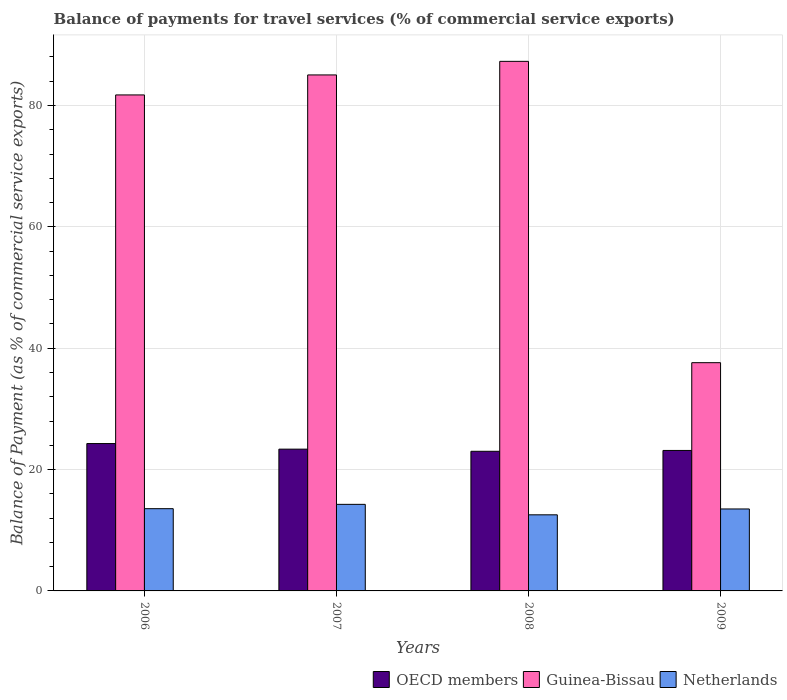How many different coloured bars are there?
Your response must be concise. 3. How many groups of bars are there?
Provide a succinct answer. 4. Are the number of bars per tick equal to the number of legend labels?
Give a very brief answer. Yes. Are the number of bars on each tick of the X-axis equal?
Provide a short and direct response. Yes. What is the label of the 3rd group of bars from the left?
Your answer should be compact. 2008. In how many cases, is the number of bars for a given year not equal to the number of legend labels?
Your answer should be compact. 0. What is the balance of payments for travel services in OECD members in 2008?
Ensure brevity in your answer.  23.01. Across all years, what is the maximum balance of payments for travel services in Guinea-Bissau?
Ensure brevity in your answer.  87.27. Across all years, what is the minimum balance of payments for travel services in Netherlands?
Your answer should be very brief. 12.54. In which year was the balance of payments for travel services in Netherlands maximum?
Provide a short and direct response. 2007. What is the total balance of payments for travel services in Guinea-Bissau in the graph?
Keep it short and to the point. 291.67. What is the difference between the balance of payments for travel services in Netherlands in 2008 and that in 2009?
Offer a terse response. -0.96. What is the difference between the balance of payments for travel services in Guinea-Bissau in 2007 and the balance of payments for travel services in Netherlands in 2009?
Your answer should be compact. 71.53. What is the average balance of payments for travel services in Guinea-Bissau per year?
Your answer should be very brief. 72.92. In the year 2009, what is the difference between the balance of payments for travel services in Netherlands and balance of payments for travel services in Guinea-Bissau?
Make the answer very short. -24.11. In how many years, is the balance of payments for travel services in Netherlands greater than 64 %?
Your response must be concise. 0. What is the ratio of the balance of payments for travel services in OECD members in 2006 to that in 2007?
Ensure brevity in your answer.  1.04. Is the difference between the balance of payments for travel services in Netherlands in 2006 and 2007 greater than the difference between the balance of payments for travel services in Guinea-Bissau in 2006 and 2007?
Your answer should be very brief. Yes. What is the difference between the highest and the second highest balance of payments for travel services in Guinea-Bissau?
Provide a short and direct response. 2.24. What is the difference between the highest and the lowest balance of payments for travel services in OECD members?
Make the answer very short. 1.28. In how many years, is the balance of payments for travel services in OECD members greater than the average balance of payments for travel services in OECD members taken over all years?
Give a very brief answer. 1. Is the sum of the balance of payments for travel services in Netherlands in 2007 and 2009 greater than the maximum balance of payments for travel services in Guinea-Bissau across all years?
Give a very brief answer. No. What does the 3rd bar from the left in 2008 represents?
Your answer should be compact. Netherlands. Is it the case that in every year, the sum of the balance of payments for travel services in OECD members and balance of payments for travel services in Netherlands is greater than the balance of payments for travel services in Guinea-Bissau?
Your answer should be compact. No. How many bars are there?
Make the answer very short. 12. Are all the bars in the graph horizontal?
Your answer should be very brief. No. How many years are there in the graph?
Your response must be concise. 4. Where does the legend appear in the graph?
Your response must be concise. Bottom right. How many legend labels are there?
Give a very brief answer. 3. What is the title of the graph?
Give a very brief answer. Balance of payments for travel services (% of commercial service exports). Does "Macedonia" appear as one of the legend labels in the graph?
Offer a very short reply. No. What is the label or title of the X-axis?
Your response must be concise. Years. What is the label or title of the Y-axis?
Keep it short and to the point. Balance of Payment (as % of commercial service exports). What is the Balance of Payment (as % of commercial service exports) of OECD members in 2006?
Your answer should be very brief. 24.29. What is the Balance of Payment (as % of commercial service exports) in Guinea-Bissau in 2006?
Offer a terse response. 81.74. What is the Balance of Payment (as % of commercial service exports) in Netherlands in 2006?
Offer a very short reply. 13.55. What is the Balance of Payment (as % of commercial service exports) of OECD members in 2007?
Your response must be concise. 23.36. What is the Balance of Payment (as % of commercial service exports) in Guinea-Bissau in 2007?
Keep it short and to the point. 85.04. What is the Balance of Payment (as % of commercial service exports) of Netherlands in 2007?
Give a very brief answer. 14.27. What is the Balance of Payment (as % of commercial service exports) of OECD members in 2008?
Your response must be concise. 23.01. What is the Balance of Payment (as % of commercial service exports) in Guinea-Bissau in 2008?
Give a very brief answer. 87.27. What is the Balance of Payment (as % of commercial service exports) in Netherlands in 2008?
Offer a terse response. 12.54. What is the Balance of Payment (as % of commercial service exports) of OECD members in 2009?
Your answer should be very brief. 23.15. What is the Balance of Payment (as % of commercial service exports) in Guinea-Bissau in 2009?
Your answer should be very brief. 37.61. What is the Balance of Payment (as % of commercial service exports) in Netherlands in 2009?
Provide a short and direct response. 13.51. Across all years, what is the maximum Balance of Payment (as % of commercial service exports) in OECD members?
Offer a terse response. 24.29. Across all years, what is the maximum Balance of Payment (as % of commercial service exports) of Guinea-Bissau?
Your answer should be compact. 87.27. Across all years, what is the maximum Balance of Payment (as % of commercial service exports) in Netherlands?
Provide a succinct answer. 14.27. Across all years, what is the minimum Balance of Payment (as % of commercial service exports) of OECD members?
Provide a short and direct response. 23.01. Across all years, what is the minimum Balance of Payment (as % of commercial service exports) of Guinea-Bissau?
Keep it short and to the point. 37.61. Across all years, what is the minimum Balance of Payment (as % of commercial service exports) of Netherlands?
Provide a succinct answer. 12.54. What is the total Balance of Payment (as % of commercial service exports) in OECD members in the graph?
Give a very brief answer. 93.81. What is the total Balance of Payment (as % of commercial service exports) in Guinea-Bissau in the graph?
Your response must be concise. 291.67. What is the total Balance of Payment (as % of commercial service exports) in Netherlands in the graph?
Give a very brief answer. 53.87. What is the difference between the Balance of Payment (as % of commercial service exports) of OECD members in 2006 and that in 2007?
Keep it short and to the point. 0.92. What is the difference between the Balance of Payment (as % of commercial service exports) in Guinea-Bissau in 2006 and that in 2007?
Make the answer very short. -3.29. What is the difference between the Balance of Payment (as % of commercial service exports) in Netherlands in 2006 and that in 2007?
Provide a succinct answer. -0.71. What is the difference between the Balance of Payment (as % of commercial service exports) in OECD members in 2006 and that in 2008?
Offer a very short reply. 1.28. What is the difference between the Balance of Payment (as % of commercial service exports) in Guinea-Bissau in 2006 and that in 2008?
Your answer should be very brief. -5.53. What is the difference between the Balance of Payment (as % of commercial service exports) in Netherlands in 2006 and that in 2008?
Offer a very short reply. 1.01. What is the difference between the Balance of Payment (as % of commercial service exports) of OECD members in 2006 and that in 2009?
Give a very brief answer. 1.14. What is the difference between the Balance of Payment (as % of commercial service exports) of Guinea-Bissau in 2006 and that in 2009?
Ensure brevity in your answer.  44.13. What is the difference between the Balance of Payment (as % of commercial service exports) in Netherlands in 2006 and that in 2009?
Ensure brevity in your answer.  0.05. What is the difference between the Balance of Payment (as % of commercial service exports) of OECD members in 2007 and that in 2008?
Make the answer very short. 0.35. What is the difference between the Balance of Payment (as % of commercial service exports) in Guinea-Bissau in 2007 and that in 2008?
Keep it short and to the point. -2.24. What is the difference between the Balance of Payment (as % of commercial service exports) in Netherlands in 2007 and that in 2008?
Offer a terse response. 1.73. What is the difference between the Balance of Payment (as % of commercial service exports) in OECD members in 2007 and that in 2009?
Provide a succinct answer. 0.21. What is the difference between the Balance of Payment (as % of commercial service exports) of Guinea-Bissau in 2007 and that in 2009?
Your answer should be very brief. 47.42. What is the difference between the Balance of Payment (as % of commercial service exports) of Netherlands in 2007 and that in 2009?
Your response must be concise. 0.76. What is the difference between the Balance of Payment (as % of commercial service exports) in OECD members in 2008 and that in 2009?
Keep it short and to the point. -0.14. What is the difference between the Balance of Payment (as % of commercial service exports) in Guinea-Bissau in 2008 and that in 2009?
Ensure brevity in your answer.  49.66. What is the difference between the Balance of Payment (as % of commercial service exports) in Netherlands in 2008 and that in 2009?
Give a very brief answer. -0.96. What is the difference between the Balance of Payment (as % of commercial service exports) in OECD members in 2006 and the Balance of Payment (as % of commercial service exports) in Guinea-Bissau in 2007?
Offer a terse response. -60.75. What is the difference between the Balance of Payment (as % of commercial service exports) of OECD members in 2006 and the Balance of Payment (as % of commercial service exports) of Netherlands in 2007?
Your answer should be very brief. 10.02. What is the difference between the Balance of Payment (as % of commercial service exports) in Guinea-Bissau in 2006 and the Balance of Payment (as % of commercial service exports) in Netherlands in 2007?
Make the answer very short. 67.47. What is the difference between the Balance of Payment (as % of commercial service exports) of OECD members in 2006 and the Balance of Payment (as % of commercial service exports) of Guinea-Bissau in 2008?
Offer a very short reply. -62.99. What is the difference between the Balance of Payment (as % of commercial service exports) of OECD members in 2006 and the Balance of Payment (as % of commercial service exports) of Netherlands in 2008?
Keep it short and to the point. 11.74. What is the difference between the Balance of Payment (as % of commercial service exports) of Guinea-Bissau in 2006 and the Balance of Payment (as % of commercial service exports) of Netherlands in 2008?
Give a very brief answer. 69.2. What is the difference between the Balance of Payment (as % of commercial service exports) in OECD members in 2006 and the Balance of Payment (as % of commercial service exports) in Guinea-Bissau in 2009?
Keep it short and to the point. -13.33. What is the difference between the Balance of Payment (as % of commercial service exports) in OECD members in 2006 and the Balance of Payment (as % of commercial service exports) in Netherlands in 2009?
Your answer should be very brief. 10.78. What is the difference between the Balance of Payment (as % of commercial service exports) in Guinea-Bissau in 2006 and the Balance of Payment (as % of commercial service exports) in Netherlands in 2009?
Provide a short and direct response. 68.24. What is the difference between the Balance of Payment (as % of commercial service exports) of OECD members in 2007 and the Balance of Payment (as % of commercial service exports) of Guinea-Bissau in 2008?
Ensure brevity in your answer.  -63.91. What is the difference between the Balance of Payment (as % of commercial service exports) of OECD members in 2007 and the Balance of Payment (as % of commercial service exports) of Netherlands in 2008?
Offer a very short reply. 10.82. What is the difference between the Balance of Payment (as % of commercial service exports) in Guinea-Bissau in 2007 and the Balance of Payment (as % of commercial service exports) in Netherlands in 2008?
Provide a succinct answer. 72.49. What is the difference between the Balance of Payment (as % of commercial service exports) of OECD members in 2007 and the Balance of Payment (as % of commercial service exports) of Guinea-Bissau in 2009?
Your answer should be compact. -14.25. What is the difference between the Balance of Payment (as % of commercial service exports) in OECD members in 2007 and the Balance of Payment (as % of commercial service exports) in Netherlands in 2009?
Ensure brevity in your answer.  9.86. What is the difference between the Balance of Payment (as % of commercial service exports) of Guinea-Bissau in 2007 and the Balance of Payment (as % of commercial service exports) of Netherlands in 2009?
Keep it short and to the point. 71.53. What is the difference between the Balance of Payment (as % of commercial service exports) in OECD members in 2008 and the Balance of Payment (as % of commercial service exports) in Guinea-Bissau in 2009?
Ensure brevity in your answer.  -14.6. What is the difference between the Balance of Payment (as % of commercial service exports) in OECD members in 2008 and the Balance of Payment (as % of commercial service exports) in Netherlands in 2009?
Your answer should be compact. 9.5. What is the difference between the Balance of Payment (as % of commercial service exports) in Guinea-Bissau in 2008 and the Balance of Payment (as % of commercial service exports) in Netherlands in 2009?
Keep it short and to the point. 73.77. What is the average Balance of Payment (as % of commercial service exports) in OECD members per year?
Give a very brief answer. 23.45. What is the average Balance of Payment (as % of commercial service exports) of Guinea-Bissau per year?
Your answer should be compact. 72.92. What is the average Balance of Payment (as % of commercial service exports) of Netherlands per year?
Ensure brevity in your answer.  13.47. In the year 2006, what is the difference between the Balance of Payment (as % of commercial service exports) of OECD members and Balance of Payment (as % of commercial service exports) of Guinea-Bissau?
Your response must be concise. -57.46. In the year 2006, what is the difference between the Balance of Payment (as % of commercial service exports) of OECD members and Balance of Payment (as % of commercial service exports) of Netherlands?
Keep it short and to the point. 10.73. In the year 2006, what is the difference between the Balance of Payment (as % of commercial service exports) of Guinea-Bissau and Balance of Payment (as % of commercial service exports) of Netherlands?
Provide a succinct answer. 68.19. In the year 2007, what is the difference between the Balance of Payment (as % of commercial service exports) in OECD members and Balance of Payment (as % of commercial service exports) in Guinea-Bissau?
Make the answer very short. -61.67. In the year 2007, what is the difference between the Balance of Payment (as % of commercial service exports) of OECD members and Balance of Payment (as % of commercial service exports) of Netherlands?
Offer a very short reply. 9.1. In the year 2007, what is the difference between the Balance of Payment (as % of commercial service exports) in Guinea-Bissau and Balance of Payment (as % of commercial service exports) in Netherlands?
Keep it short and to the point. 70.77. In the year 2008, what is the difference between the Balance of Payment (as % of commercial service exports) in OECD members and Balance of Payment (as % of commercial service exports) in Guinea-Bissau?
Your answer should be very brief. -64.26. In the year 2008, what is the difference between the Balance of Payment (as % of commercial service exports) in OECD members and Balance of Payment (as % of commercial service exports) in Netherlands?
Offer a very short reply. 10.47. In the year 2008, what is the difference between the Balance of Payment (as % of commercial service exports) in Guinea-Bissau and Balance of Payment (as % of commercial service exports) in Netherlands?
Provide a succinct answer. 74.73. In the year 2009, what is the difference between the Balance of Payment (as % of commercial service exports) of OECD members and Balance of Payment (as % of commercial service exports) of Guinea-Bissau?
Provide a succinct answer. -14.46. In the year 2009, what is the difference between the Balance of Payment (as % of commercial service exports) of OECD members and Balance of Payment (as % of commercial service exports) of Netherlands?
Your answer should be very brief. 9.64. In the year 2009, what is the difference between the Balance of Payment (as % of commercial service exports) of Guinea-Bissau and Balance of Payment (as % of commercial service exports) of Netherlands?
Give a very brief answer. 24.11. What is the ratio of the Balance of Payment (as % of commercial service exports) of OECD members in 2006 to that in 2007?
Provide a succinct answer. 1.04. What is the ratio of the Balance of Payment (as % of commercial service exports) in Guinea-Bissau in 2006 to that in 2007?
Make the answer very short. 0.96. What is the ratio of the Balance of Payment (as % of commercial service exports) in OECD members in 2006 to that in 2008?
Provide a succinct answer. 1.06. What is the ratio of the Balance of Payment (as % of commercial service exports) in Guinea-Bissau in 2006 to that in 2008?
Make the answer very short. 0.94. What is the ratio of the Balance of Payment (as % of commercial service exports) in Netherlands in 2006 to that in 2008?
Offer a very short reply. 1.08. What is the ratio of the Balance of Payment (as % of commercial service exports) in OECD members in 2006 to that in 2009?
Offer a very short reply. 1.05. What is the ratio of the Balance of Payment (as % of commercial service exports) in Guinea-Bissau in 2006 to that in 2009?
Make the answer very short. 2.17. What is the ratio of the Balance of Payment (as % of commercial service exports) in OECD members in 2007 to that in 2008?
Offer a very short reply. 1.02. What is the ratio of the Balance of Payment (as % of commercial service exports) of Guinea-Bissau in 2007 to that in 2008?
Your answer should be compact. 0.97. What is the ratio of the Balance of Payment (as % of commercial service exports) in Netherlands in 2007 to that in 2008?
Give a very brief answer. 1.14. What is the ratio of the Balance of Payment (as % of commercial service exports) of OECD members in 2007 to that in 2009?
Offer a very short reply. 1.01. What is the ratio of the Balance of Payment (as % of commercial service exports) in Guinea-Bissau in 2007 to that in 2009?
Your answer should be compact. 2.26. What is the ratio of the Balance of Payment (as % of commercial service exports) in Netherlands in 2007 to that in 2009?
Ensure brevity in your answer.  1.06. What is the ratio of the Balance of Payment (as % of commercial service exports) in Guinea-Bissau in 2008 to that in 2009?
Offer a terse response. 2.32. What is the difference between the highest and the second highest Balance of Payment (as % of commercial service exports) in OECD members?
Give a very brief answer. 0.92. What is the difference between the highest and the second highest Balance of Payment (as % of commercial service exports) in Guinea-Bissau?
Your answer should be very brief. 2.24. What is the difference between the highest and the second highest Balance of Payment (as % of commercial service exports) of Netherlands?
Offer a terse response. 0.71. What is the difference between the highest and the lowest Balance of Payment (as % of commercial service exports) of OECD members?
Your response must be concise. 1.28. What is the difference between the highest and the lowest Balance of Payment (as % of commercial service exports) of Guinea-Bissau?
Offer a terse response. 49.66. What is the difference between the highest and the lowest Balance of Payment (as % of commercial service exports) of Netherlands?
Make the answer very short. 1.73. 